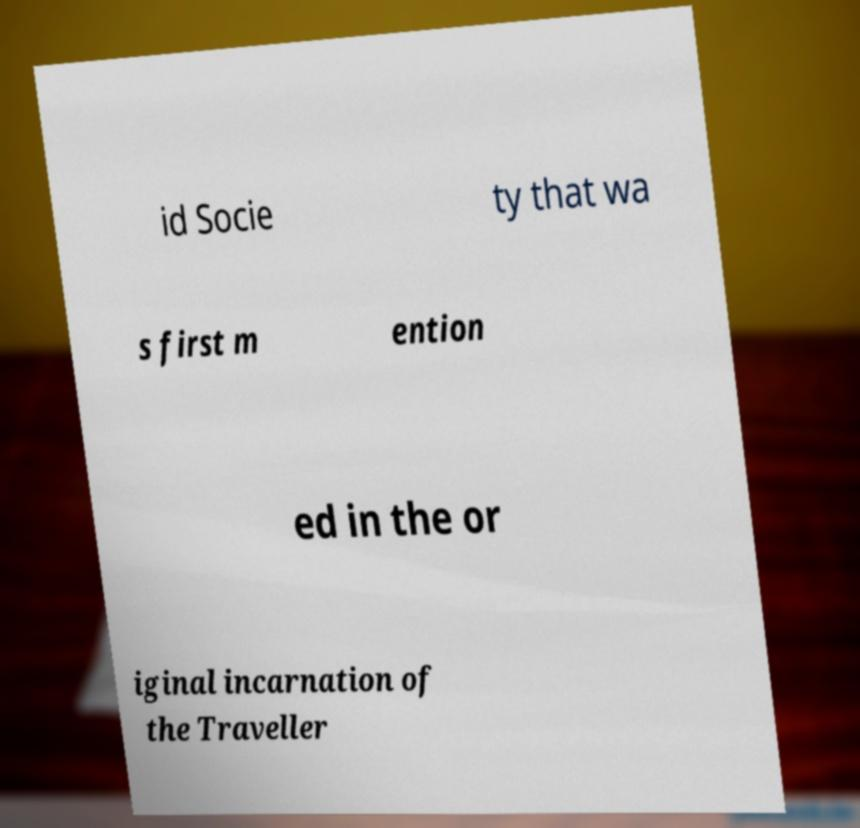Please identify and transcribe the text found in this image. id Socie ty that wa s first m ention ed in the or iginal incarnation of the Traveller 